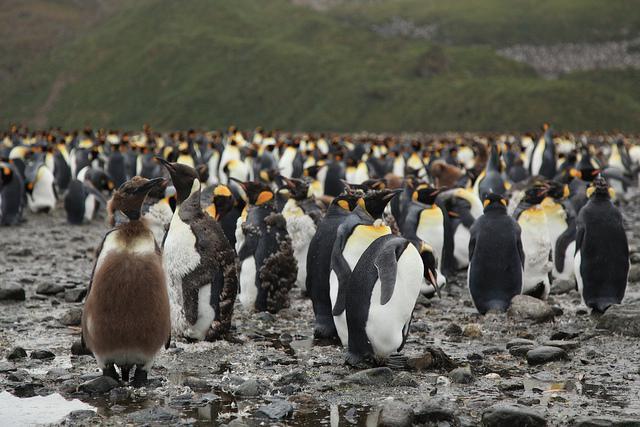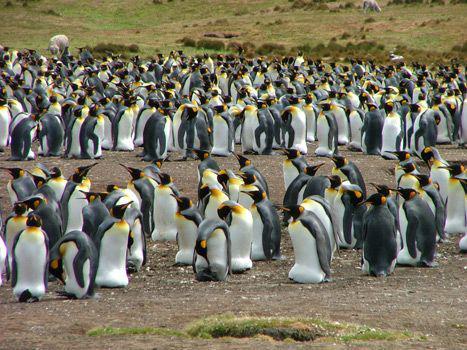The first image is the image on the left, the second image is the image on the right. For the images displayed, is the sentence "At least one of the images features a young penguin in brown downy feathers, at the foreground of the scene." factually correct? Answer yes or no. Yes. 